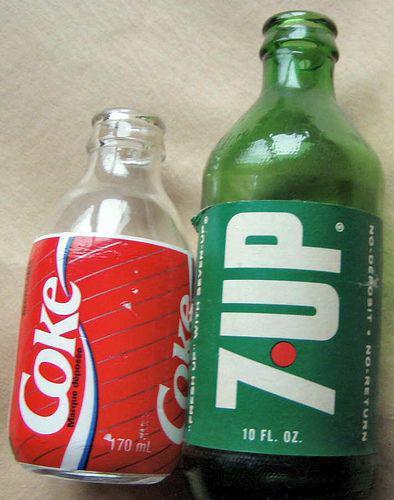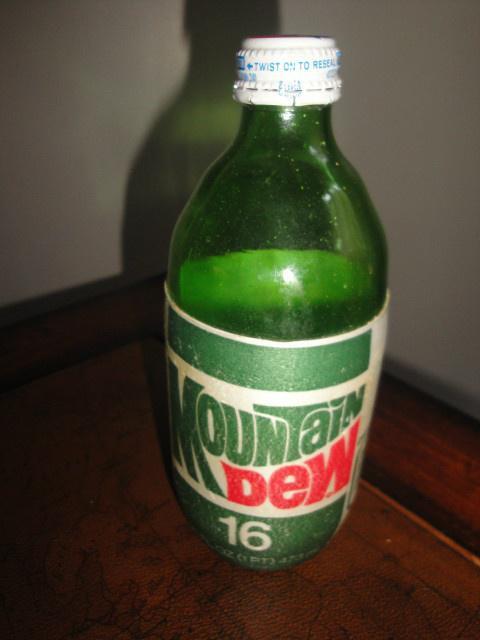The first image is the image on the left, the second image is the image on the right. Analyze the images presented: Is the assertion "All of the bottles have caps." valid? Answer yes or no. No. The first image is the image on the left, the second image is the image on the right. Analyze the images presented: Is the assertion "The right image contains at least twice as many soda bottles as the left image." valid? Answer yes or no. No. 